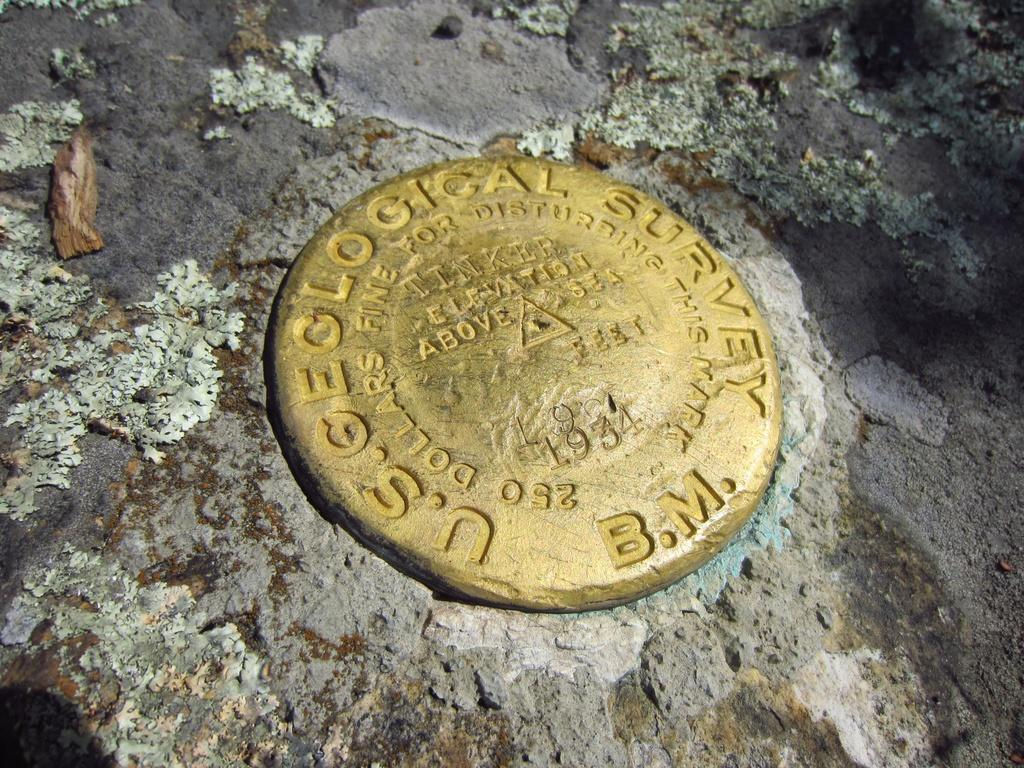Provide a one-sentence caption for the provided image. U.S Geological survey gold in rocks b.m type of coin. 